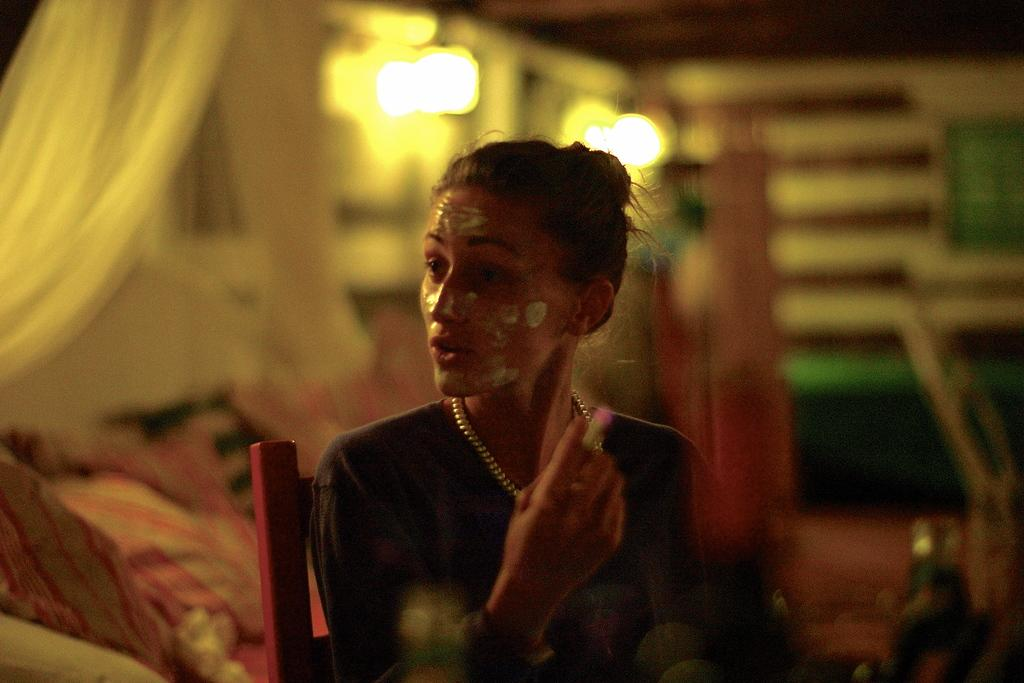Who is the main subject in the image? There is a lady in the image. What is the lady doing in the image? The lady is sitting on a chair. Can you describe the background of the image? The background of the image is blurred. What direction is the lady facing in the image? The direction the lady is facing cannot be determined from the image, as the background is blurred. What effect does the lady have on the page in the image? There is no page present in the image, so it is not possible to determine any effect the lady might have on a page. 